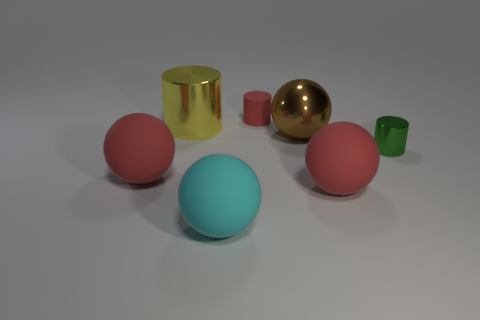Add 1 small purple things. How many objects exist? 8 Subtract all cylinders. How many objects are left? 4 Add 2 big brown metallic things. How many big brown metallic things exist? 3 Subtract 0 purple spheres. How many objects are left? 7 Subtract all large purple shiny blocks. Subtract all tiny metallic cylinders. How many objects are left? 6 Add 3 large brown shiny spheres. How many large brown shiny spheres are left? 4 